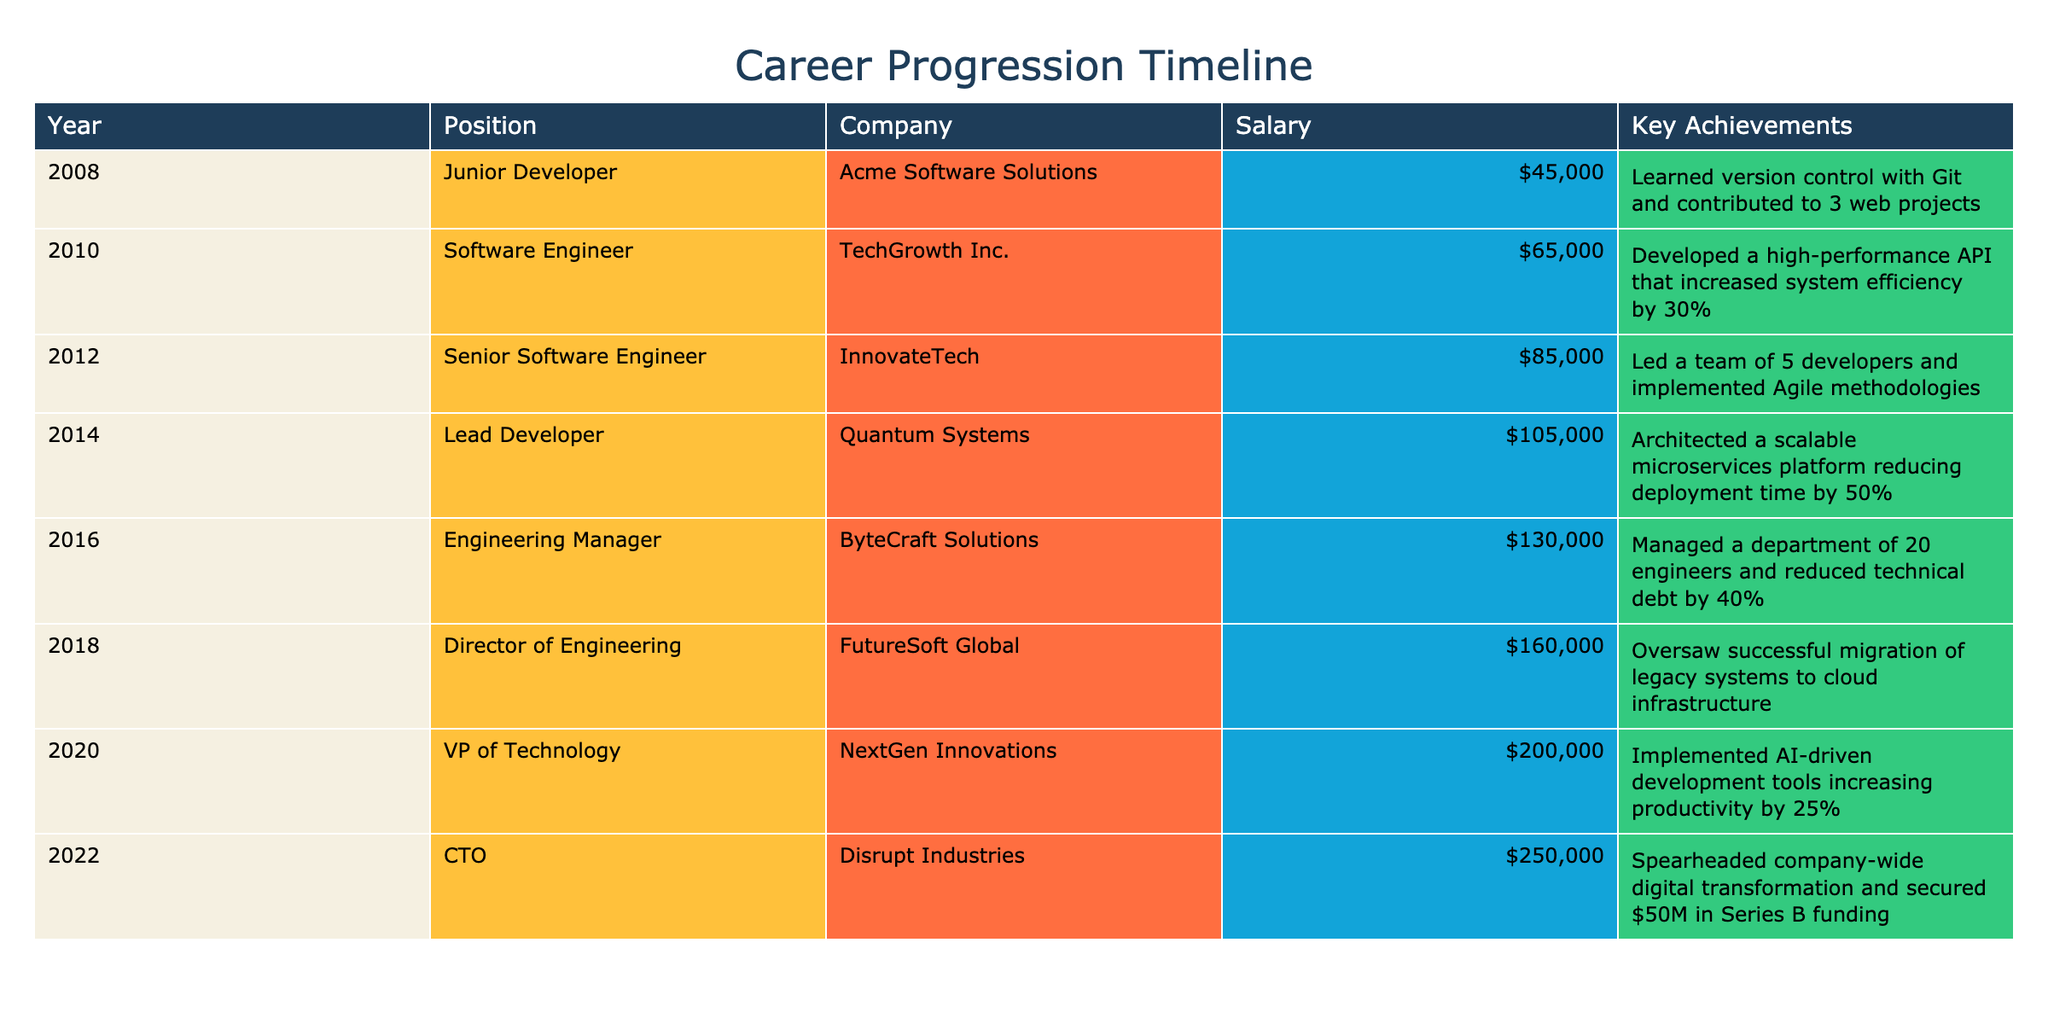What was the salary of the Engineering Manager in 2016? The salary for the position of Engineering Manager in 2016 is $130,000 as indicated in the table under the "Salary" column for that year.
Answer: $130,000 What is the key achievement of the Lead Developer in 2014? The key achievement listed for the Lead Developer in 2014 is "Architected a scalable microservices platform reducing deployment time by 50%."
Answer: Architected a scalable microservices platform reducing deployment time by 50% How many years did it take to progress from Junior Developer to CTO? The time span from Junior Developer in 2008 to CTO in 2022 is 14 years, calculated by subtracting 2008 from 2022.
Answer: 14 years What was the average salary during the senior roles (Senior Software Engineer to CTO)? The salaries from Senior Software Engineer ($85,000), Lead Developer ($105,000), Engineering Manager ($130,000), Director of Engineering ($160,000), VP of Technology ($200,000), and CTO ($250,000) sum to $1,030,000. Dividing by the 6 roles gives an average salary of $171,667.
Answer: $171,667 Did the individual achieve any significant funding as a CTO? Yes, the table notes that as CTO, the person secured $50 million in Series B funding, indicating a significant achievement.
Answer: Yes What was the progression in the job titles from 2010 to 2018? The individual started as Software Engineer in 2010, then became Senior Software Engineer in 2012, followed by Lead Developer in 2014, Engineering Manager in 2016, and finally Director of Engineering in 2018.
Answer: Software Engineer, Senior Software Engineer, Lead Developer, Engineering Manager, Director of Engineering Was the salary in 2010 higher than that in 2008? Yes, the salary in 2010 was $65,000, which is higher than the salary in 2008, which was $45,000.
Answer: Yes What was the total number of positions held from 2008 to 2022? Counting each position listed from Junior Developer through CTO, there are a total of 8 positions: Junior Developer, Software Engineer, Senior Software Engineer, Lead Developer, Engineering Manager, Director of Engineering, VP of Technology, and CTO.
Answer: 8 positions 